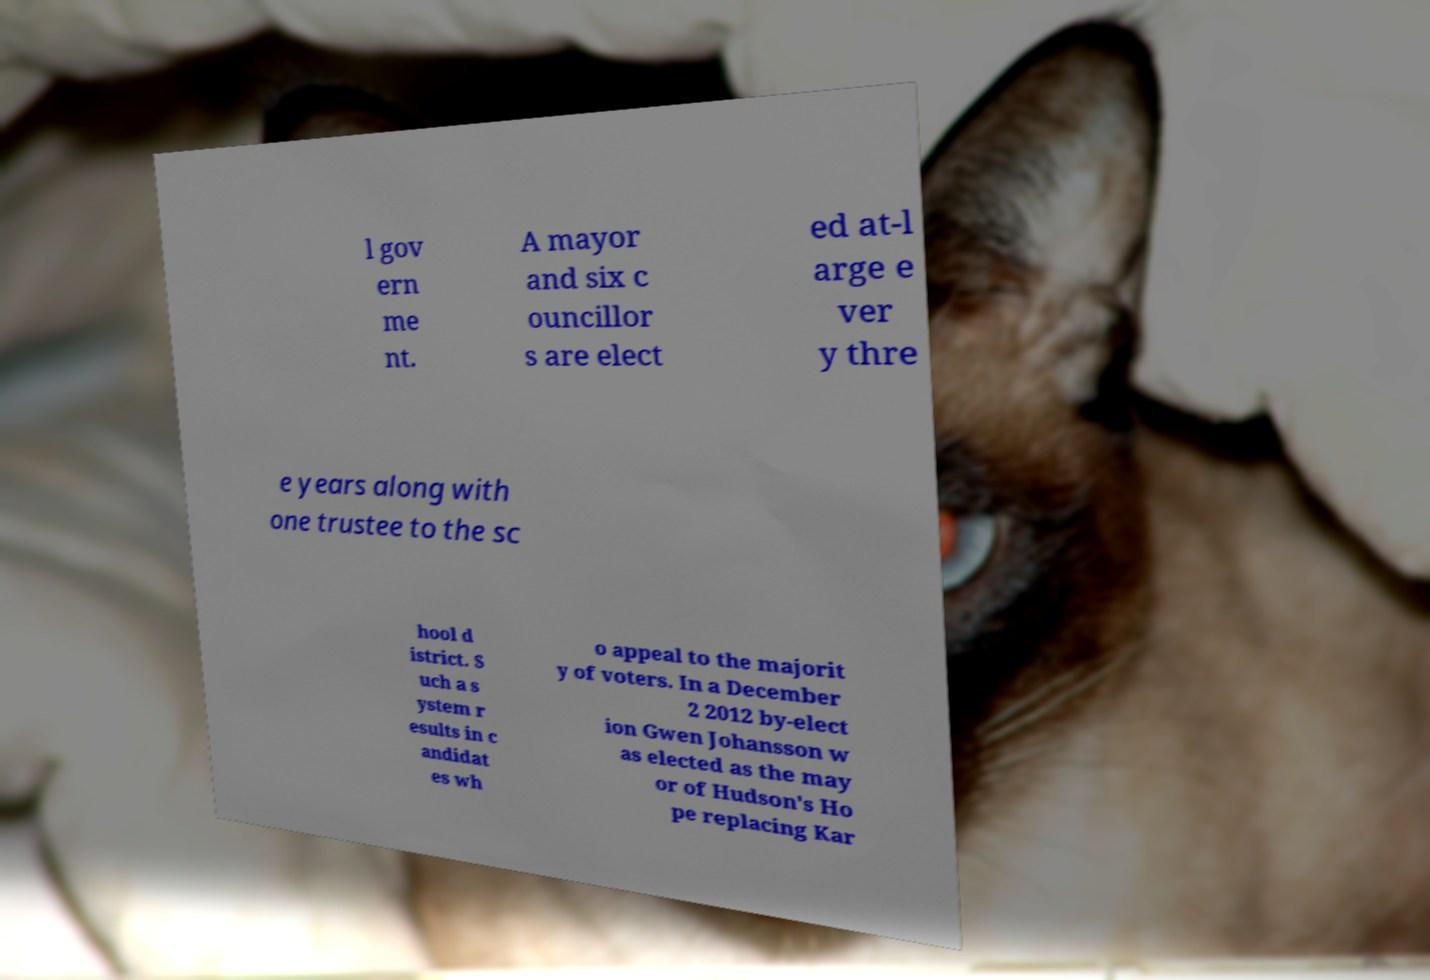What messages or text are displayed in this image? I need them in a readable, typed format. l gov ern me nt. A mayor and six c ouncillor s are elect ed at-l arge e ver y thre e years along with one trustee to the sc hool d istrict. S uch a s ystem r esults in c andidat es wh o appeal to the majorit y of voters. In a December 2 2012 by-elect ion Gwen Johansson w as elected as the may or of Hudson's Ho pe replacing Kar 